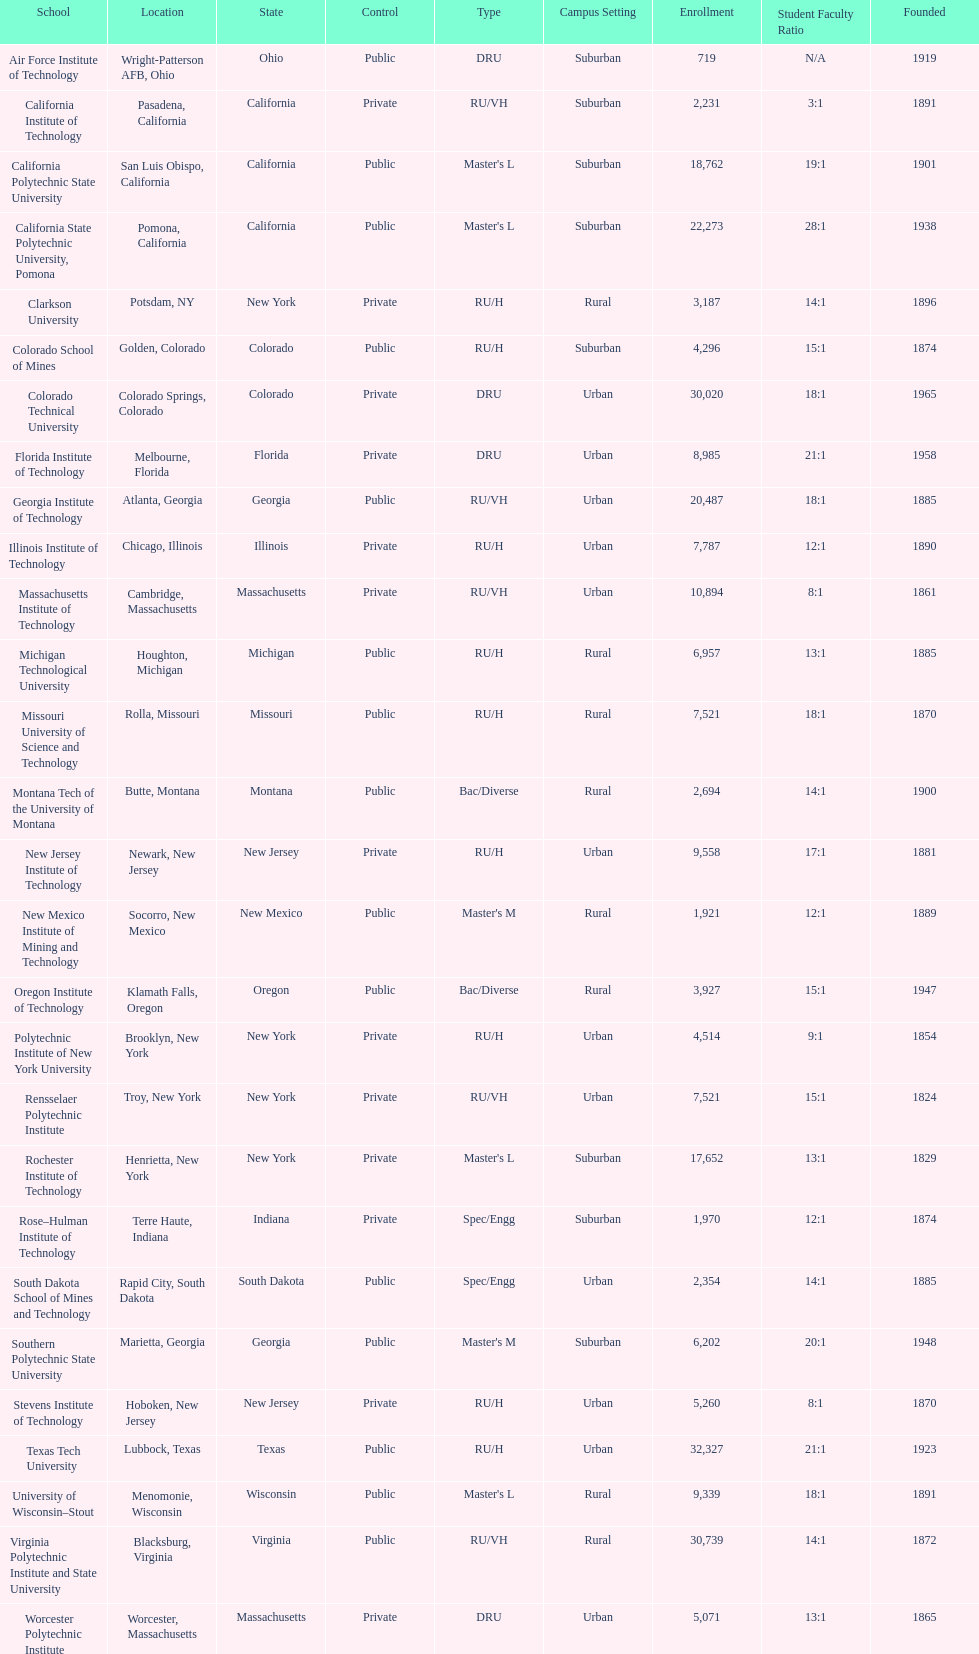What is the number of us technological schools in the state of california? 3. 